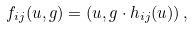<formula> <loc_0><loc_0><loc_500><loc_500>f _ { i j } ( u , g ) = ( u , g \cdot h _ { i j } ( u ) ) \, ,</formula> 